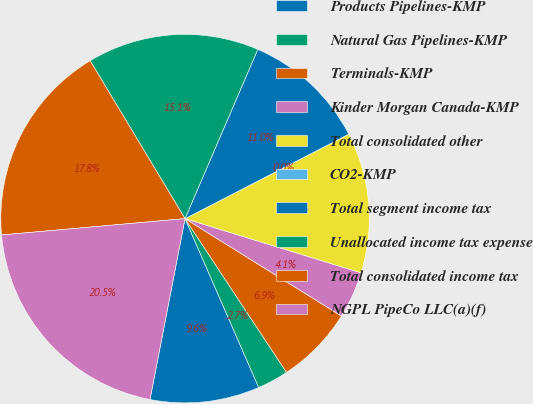<chart> <loc_0><loc_0><loc_500><loc_500><pie_chart><fcel>Products Pipelines-KMP<fcel>Natural Gas Pipelines-KMP<fcel>Terminals-KMP<fcel>Kinder Morgan Canada-KMP<fcel>Total consolidated other<fcel>CO2-KMP<fcel>Total segment income tax<fcel>Unallocated income tax expense<fcel>Total consolidated income tax<fcel>NGPL PipeCo LLC(a)(f)<nl><fcel>9.59%<fcel>2.74%<fcel>6.85%<fcel>4.11%<fcel>12.33%<fcel>0.0%<fcel>10.96%<fcel>15.07%<fcel>17.8%<fcel>20.54%<nl></chart> 